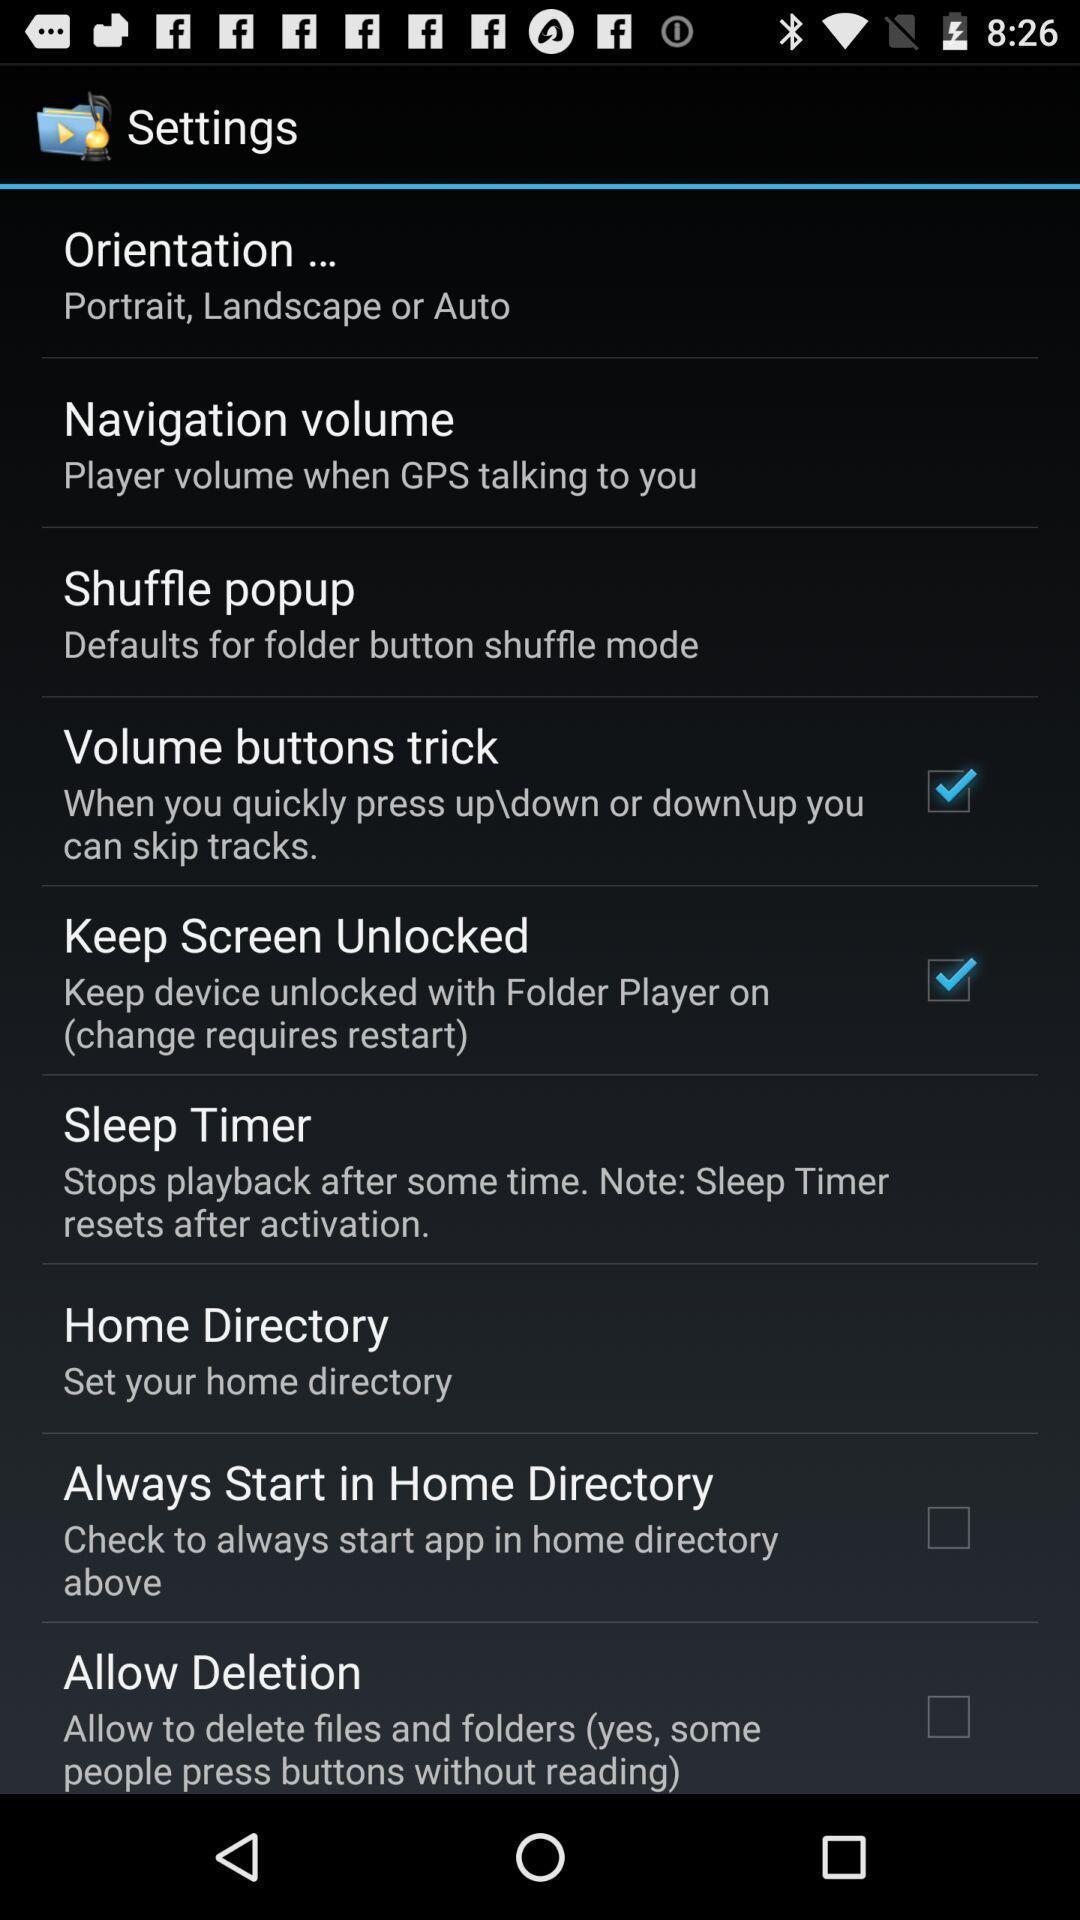Summarize the main components in this picture. Settings page. 